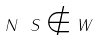<formula> <loc_0><loc_0><loc_500><loc_500>N \ S \notin W</formula> 